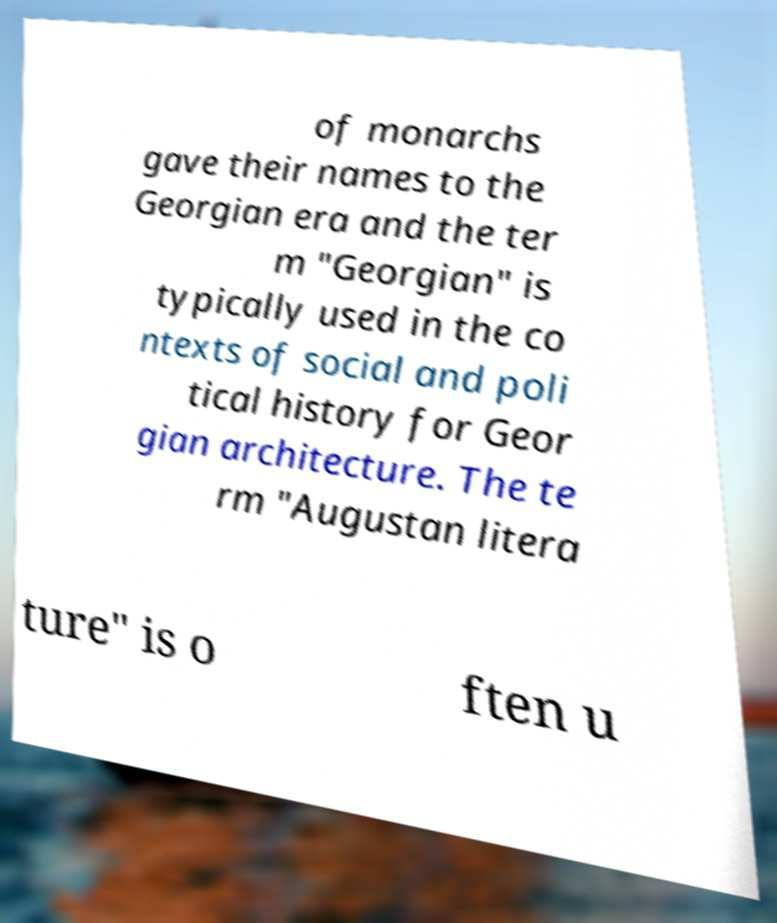For documentation purposes, I need the text within this image transcribed. Could you provide that? of monarchs gave their names to the Georgian era and the ter m "Georgian" is typically used in the co ntexts of social and poli tical history for Geor gian architecture. The te rm "Augustan litera ture" is o ften u 